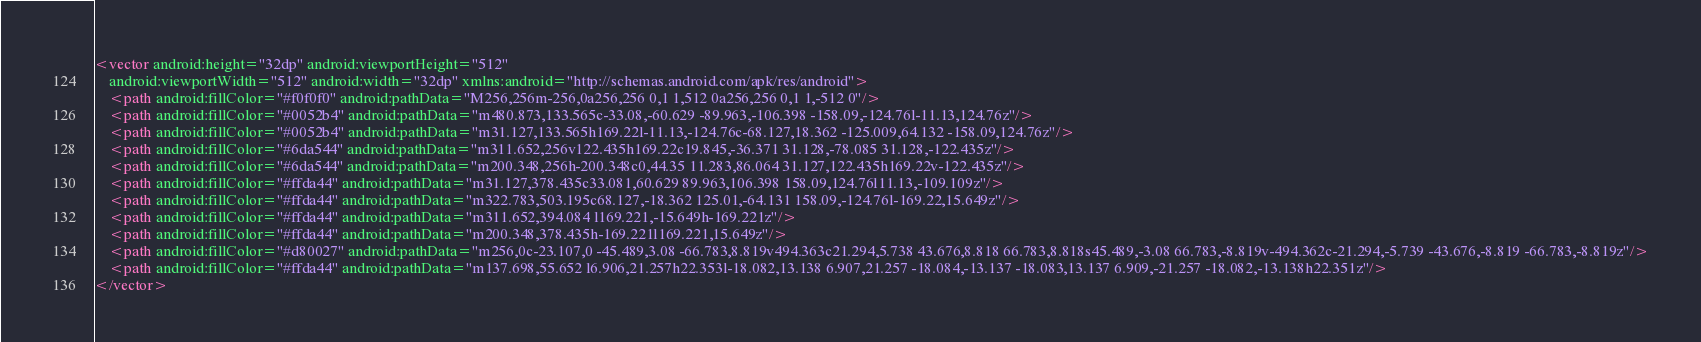<code> <loc_0><loc_0><loc_500><loc_500><_XML_><vector android:height="32dp" android:viewportHeight="512"
    android:viewportWidth="512" android:width="32dp" xmlns:android="http://schemas.android.com/apk/res/android">
    <path android:fillColor="#f0f0f0" android:pathData="M256,256m-256,0a256,256 0,1 1,512 0a256,256 0,1 1,-512 0"/>
    <path android:fillColor="#0052b4" android:pathData="m480.873,133.565c-33.08,-60.629 -89.963,-106.398 -158.09,-124.76l-11.13,124.76z"/>
    <path android:fillColor="#0052b4" android:pathData="m31.127,133.565h169.22l-11.13,-124.76c-68.127,18.362 -125.009,64.132 -158.09,124.76z"/>
    <path android:fillColor="#6da544" android:pathData="m311.652,256v122.435h169.22c19.845,-36.371 31.128,-78.085 31.128,-122.435z"/>
    <path android:fillColor="#6da544" android:pathData="m200.348,256h-200.348c0,44.35 11.283,86.064 31.127,122.435h169.22v-122.435z"/>
    <path android:fillColor="#ffda44" android:pathData="m31.127,378.435c33.081,60.629 89.963,106.398 158.09,124.76l11.13,-109.109z"/>
    <path android:fillColor="#ffda44" android:pathData="m322.783,503.195c68.127,-18.362 125.01,-64.131 158.09,-124.76l-169.22,15.649z"/>
    <path android:fillColor="#ffda44" android:pathData="m311.652,394.084 l169.221,-15.649h-169.221z"/>
    <path android:fillColor="#ffda44" android:pathData="m200.348,378.435h-169.221l169.221,15.649z"/>
    <path android:fillColor="#d80027" android:pathData="m256,0c-23.107,0 -45.489,3.08 -66.783,8.819v494.363c21.294,5.738 43.676,8.818 66.783,8.818s45.489,-3.08 66.783,-8.819v-494.362c-21.294,-5.739 -43.676,-8.819 -66.783,-8.819z"/>
    <path android:fillColor="#ffda44" android:pathData="m137.698,55.652 l6.906,21.257h22.353l-18.082,13.138 6.907,21.257 -18.084,-13.137 -18.083,13.137 6.909,-21.257 -18.082,-13.138h22.351z"/>
</vector>
</code> 